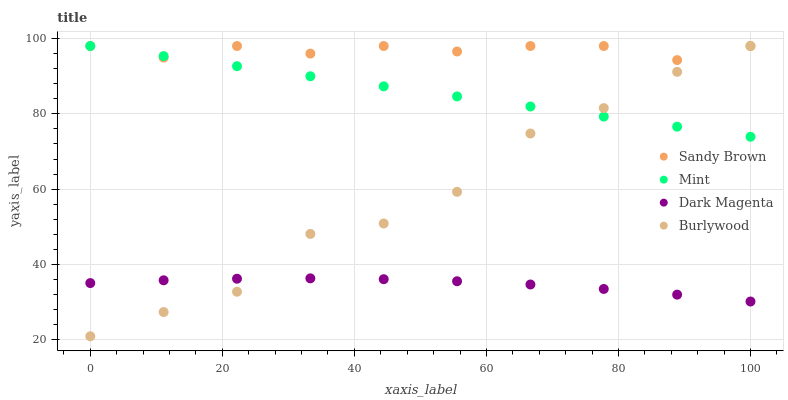Does Dark Magenta have the minimum area under the curve?
Answer yes or no. Yes. Does Sandy Brown have the maximum area under the curve?
Answer yes or no. Yes. Does Mint have the minimum area under the curve?
Answer yes or no. No. Does Mint have the maximum area under the curve?
Answer yes or no. No. Is Mint the smoothest?
Answer yes or no. Yes. Is Burlywood the roughest?
Answer yes or no. Yes. Is Sandy Brown the smoothest?
Answer yes or no. No. Is Sandy Brown the roughest?
Answer yes or no. No. Does Burlywood have the lowest value?
Answer yes or no. Yes. Does Mint have the lowest value?
Answer yes or no. No. Does Sandy Brown have the highest value?
Answer yes or no. Yes. Does Dark Magenta have the highest value?
Answer yes or no. No. Is Dark Magenta less than Sandy Brown?
Answer yes or no. Yes. Is Sandy Brown greater than Dark Magenta?
Answer yes or no. Yes. Does Mint intersect Sandy Brown?
Answer yes or no. Yes. Is Mint less than Sandy Brown?
Answer yes or no. No. Is Mint greater than Sandy Brown?
Answer yes or no. No. Does Dark Magenta intersect Sandy Brown?
Answer yes or no. No. 